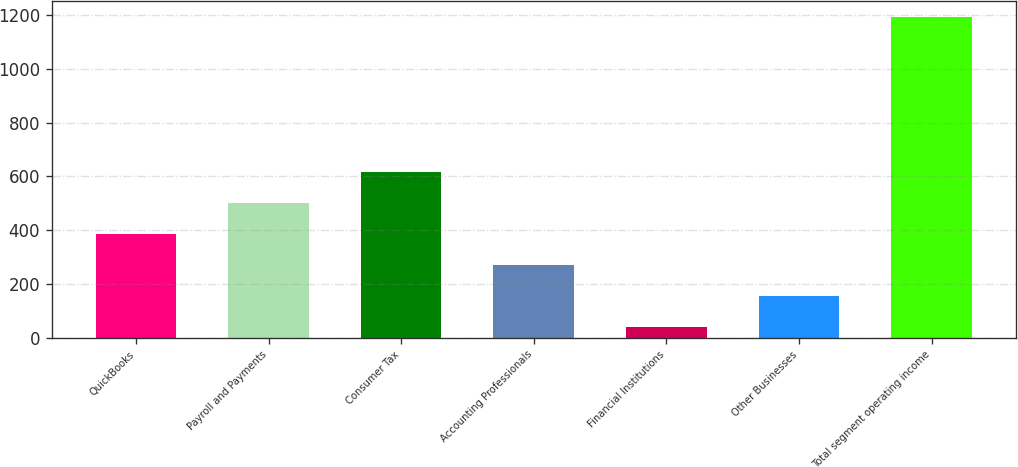Convert chart to OTSL. <chart><loc_0><loc_0><loc_500><loc_500><bar_chart><fcel>QuickBooks<fcel>Payroll and Payments<fcel>Consumer Tax<fcel>Accounting Professionals<fcel>Financial Institutions<fcel>Other Businesses<fcel>Total segment operating income<nl><fcel>385.57<fcel>501.16<fcel>616.75<fcel>269.98<fcel>38.8<fcel>154.39<fcel>1194.7<nl></chart> 